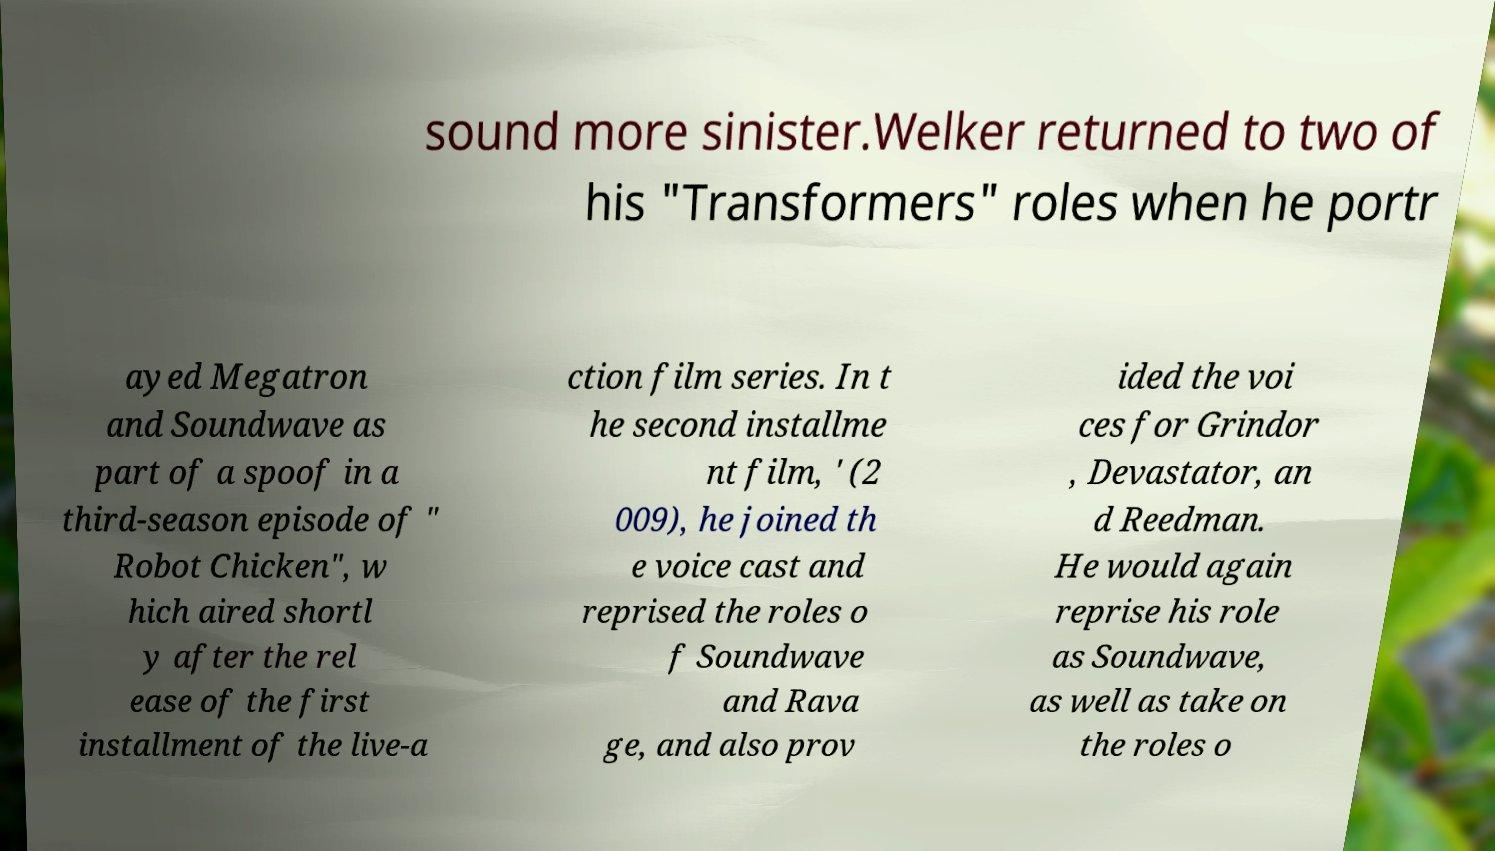Can you accurately transcribe the text from the provided image for me? sound more sinister.Welker returned to two of his "Transformers" roles when he portr ayed Megatron and Soundwave as part of a spoof in a third-season episode of " Robot Chicken", w hich aired shortl y after the rel ease of the first installment of the live-a ction film series. In t he second installme nt film, ' (2 009), he joined th e voice cast and reprised the roles o f Soundwave and Rava ge, and also prov ided the voi ces for Grindor , Devastator, an d Reedman. He would again reprise his role as Soundwave, as well as take on the roles o 